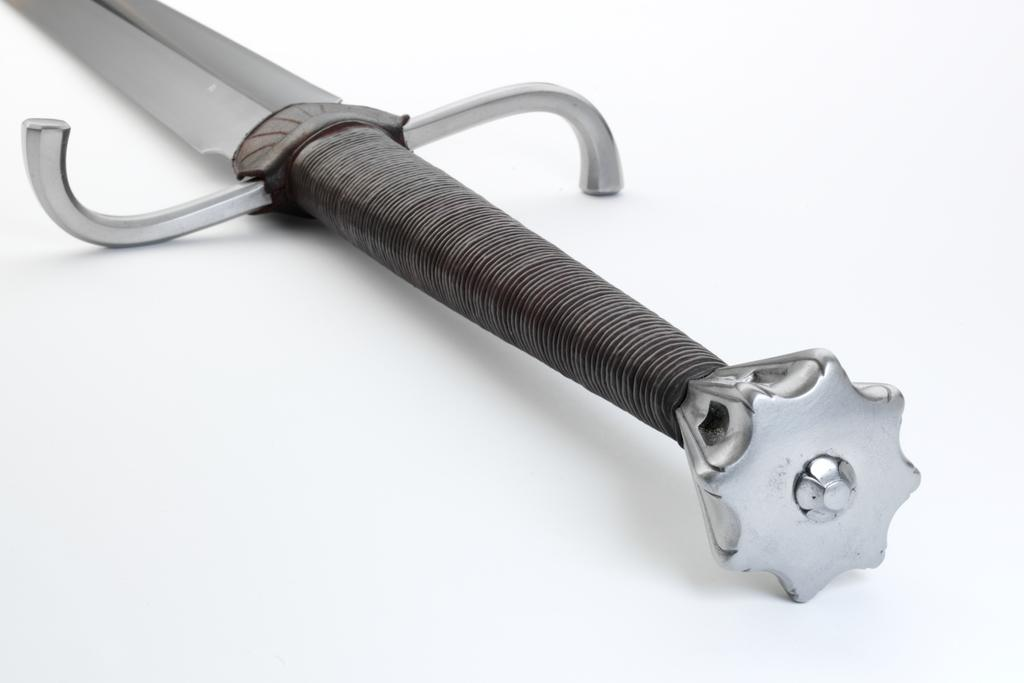What object is present in the image? There is a sword in the image. What type of reaction can be seen from the sword in the image? There is no reaction from the sword in the image, as it is an inanimate object. What type of collar is visible on the sword in the image? There is no collar present on the sword in the image, as it is not an animal or a person. 